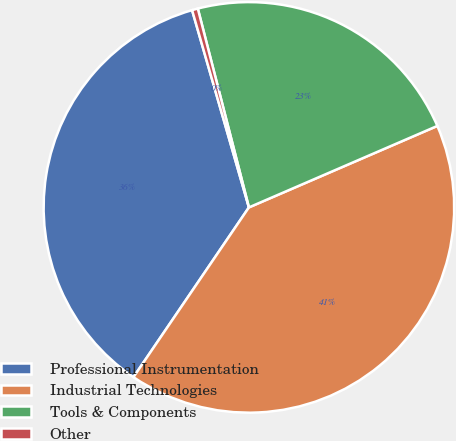Convert chart. <chart><loc_0><loc_0><loc_500><loc_500><pie_chart><fcel>Professional Instrumentation<fcel>Industrial Technologies<fcel>Tools & Components<fcel>Other<nl><fcel>36.03%<fcel>41.0%<fcel>22.51%<fcel>0.46%<nl></chart> 